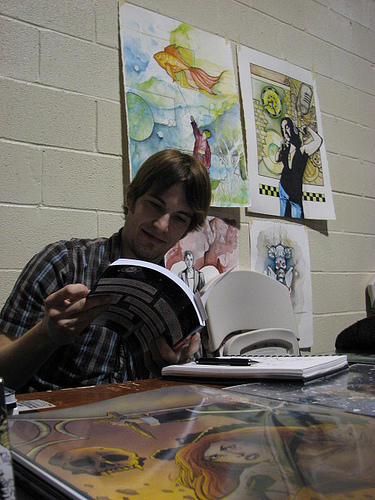<image>
Is the man on the pen? No. The man is not positioned on the pen. They may be near each other, but the man is not supported by or resting on top of the pen. 